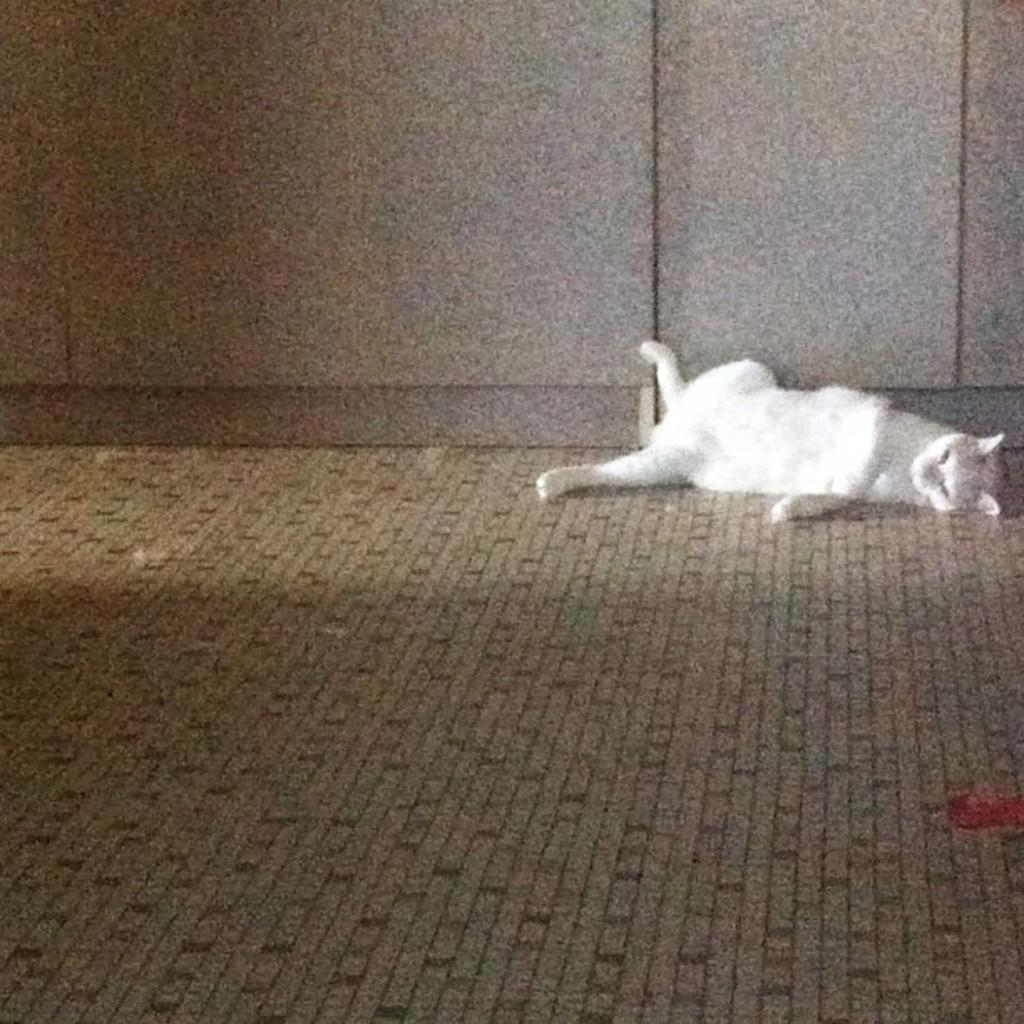What type of animal is in the image? There is a cat in the image. What color is the cat? The cat is white in color. What position is the cat in? The cat is lying on the floor. What type of surface is visible in the image? There is a floor visible in the image. What else can be seen in the background of the image? There is a wall visible in the image. What type of property does the cat own in the image? The cat does not own any property in the image, as cats are not capable of owning property. 